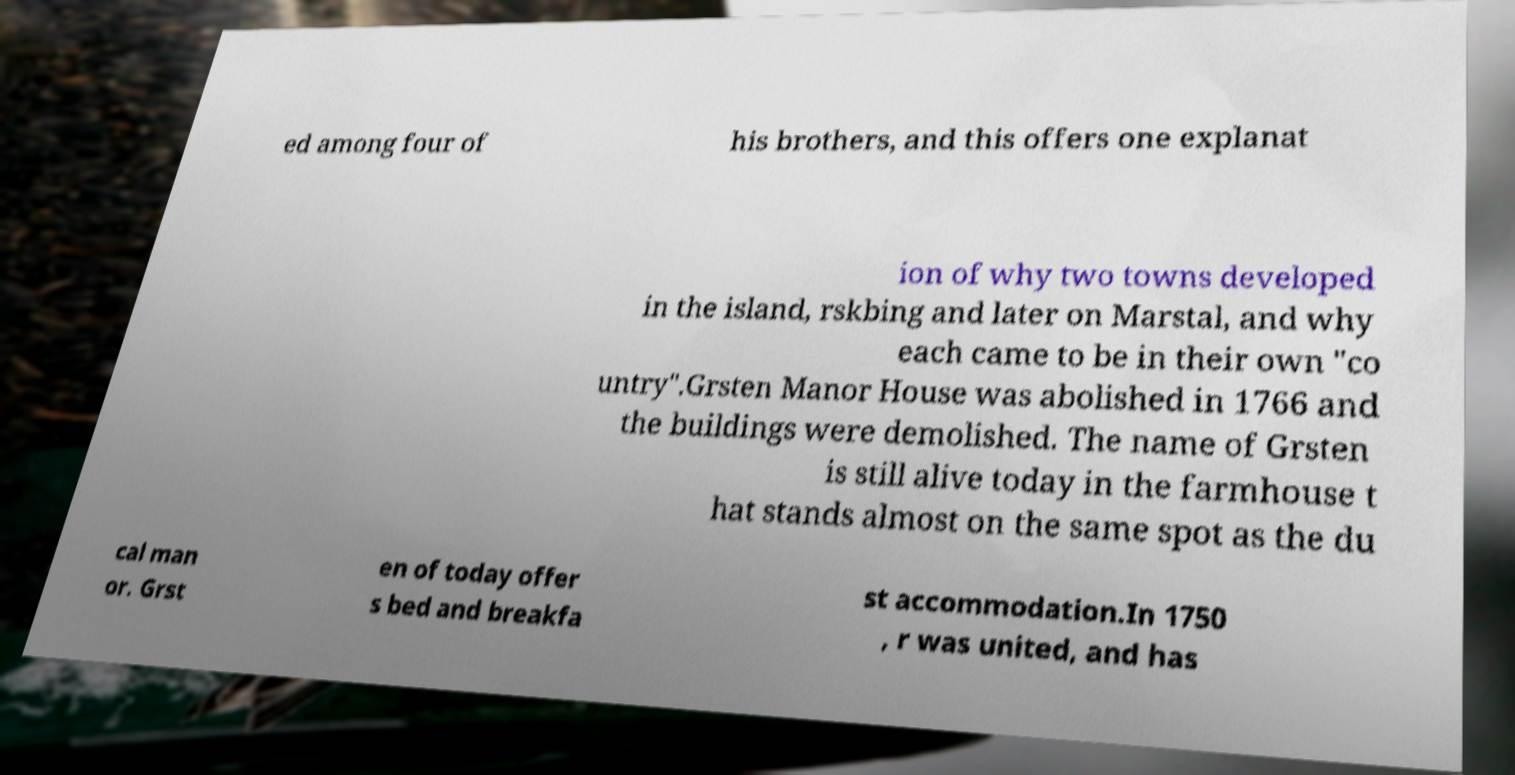What messages or text are displayed in this image? I need them in a readable, typed format. ed among four of his brothers, and this offers one explanat ion of why two towns developed in the island, rskbing and later on Marstal, and why each came to be in their own "co untry".Grsten Manor House was abolished in 1766 and the buildings were demolished. The name of Grsten is still alive today in the farmhouse t hat stands almost on the same spot as the du cal man or. Grst en of today offer s bed and breakfa st accommodation.In 1750 , r was united, and has 